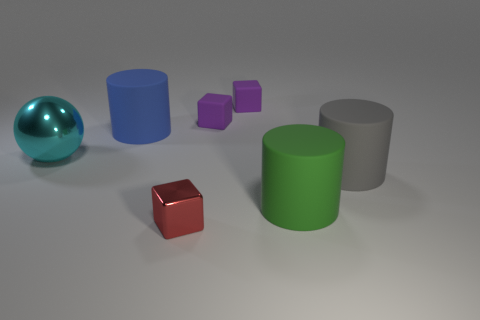Add 2 red blocks. How many objects exist? 9 Subtract all spheres. How many objects are left? 6 Subtract all tiny green matte spheres. Subtract all gray matte cylinders. How many objects are left? 6 Add 4 small purple rubber blocks. How many small purple rubber blocks are left? 6 Add 4 large green rubber things. How many large green rubber things exist? 5 Subtract 0 green balls. How many objects are left? 7 